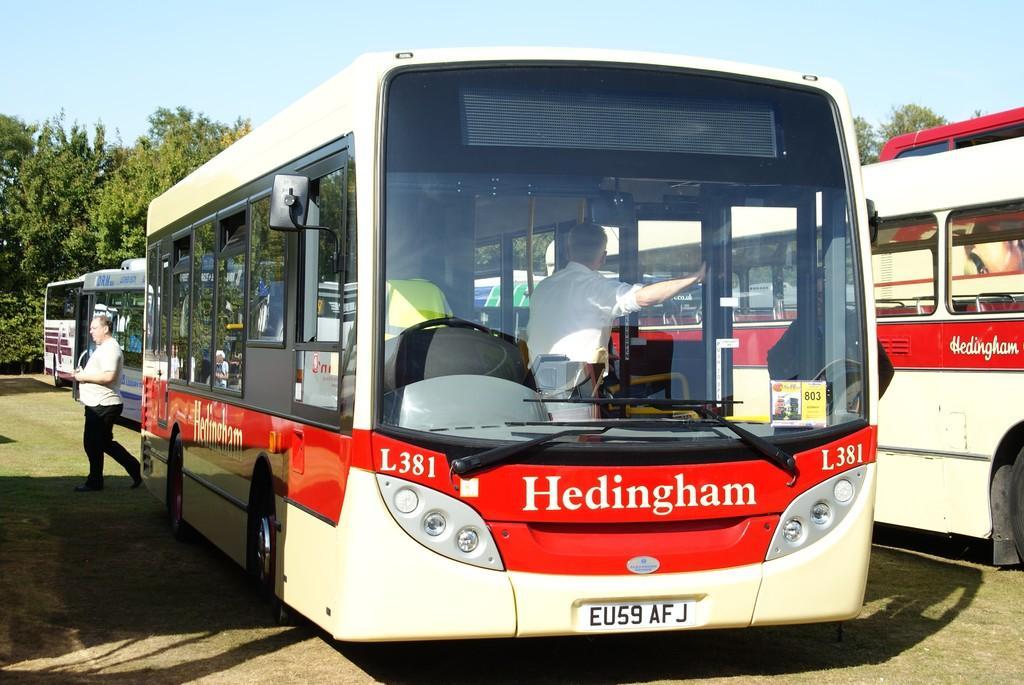Can you describe this image briefly? In the foreground of this image, there are buses on the road behind it there is a man walking and in the background, there are trees, buses and the sky. 